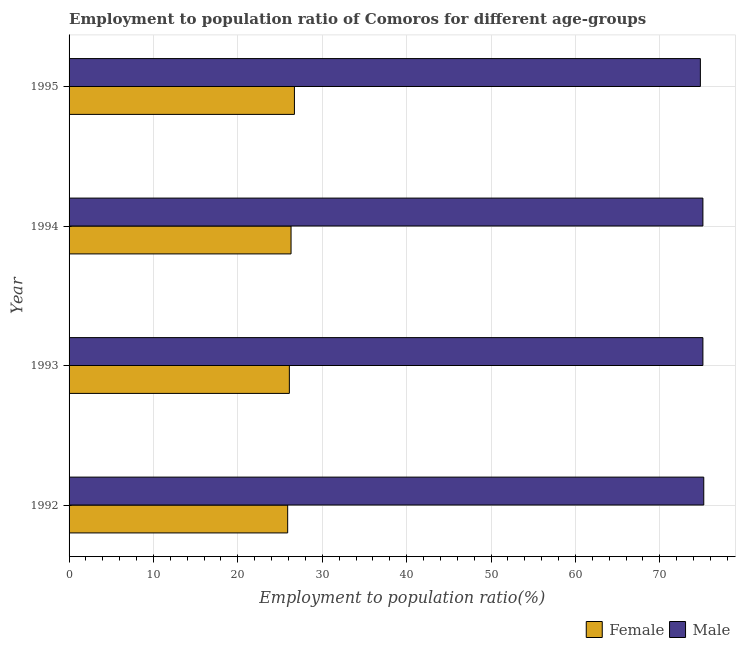Are the number of bars per tick equal to the number of legend labels?
Your answer should be compact. Yes. How many bars are there on the 4th tick from the top?
Keep it short and to the point. 2. What is the label of the 4th group of bars from the top?
Make the answer very short. 1992. What is the employment to population ratio(female) in 1992?
Offer a very short reply. 25.9. Across all years, what is the maximum employment to population ratio(male)?
Provide a short and direct response. 75.2. Across all years, what is the minimum employment to population ratio(male)?
Provide a succinct answer. 74.8. What is the total employment to population ratio(female) in the graph?
Provide a succinct answer. 105. What is the difference between the employment to population ratio(male) in 1992 and that in 1995?
Make the answer very short. 0.4. What is the difference between the employment to population ratio(female) in 1995 and the employment to population ratio(male) in 1993?
Make the answer very short. -48.4. What is the average employment to population ratio(male) per year?
Your response must be concise. 75.05. In the year 1992, what is the difference between the employment to population ratio(female) and employment to population ratio(male)?
Offer a terse response. -49.3. What is the ratio of the employment to population ratio(male) in 1993 to that in 1994?
Make the answer very short. 1. What is the difference between the highest and the second highest employment to population ratio(male)?
Provide a succinct answer. 0.1. What does the 1st bar from the top in 1994 represents?
Provide a succinct answer. Male. What does the 2nd bar from the bottom in 1995 represents?
Provide a succinct answer. Male. How many bars are there?
Your answer should be very brief. 8. Are all the bars in the graph horizontal?
Give a very brief answer. Yes. What is the difference between two consecutive major ticks on the X-axis?
Keep it short and to the point. 10. Are the values on the major ticks of X-axis written in scientific E-notation?
Offer a very short reply. No. Does the graph contain grids?
Make the answer very short. Yes. Where does the legend appear in the graph?
Your answer should be very brief. Bottom right. What is the title of the graph?
Provide a succinct answer. Employment to population ratio of Comoros for different age-groups. What is the Employment to population ratio(%) of Female in 1992?
Your response must be concise. 25.9. What is the Employment to population ratio(%) in Male in 1992?
Give a very brief answer. 75.2. What is the Employment to population ratio(%) in Female in 1993?
Make the answer very short. 26.1. What is the Employment to population ratio(%) in Male in 1993?
Your response must be concise. 75.1. What is the Employment to population ratio(%) in Female in 1994?
Make the answer very short. 26.3. What is the Employment to population ratio(%) of Male in 1994?
Keep it short and to the point. 75.1. What is the Employment to population ratio(%) in Female in 1995?
Provide a succinct answer. 26.7. What is the Employment to population ratio(%) in Male in 1995?
Give a very brief answer. 74.8. Across all years, what is the maximum Employment to population ratio(%) of Female?
Provide a succinct answer. 26.7. Across all years, what is the maximum Employment to population ratio(%) of Male?
Your answer should be very brief. 75.2. Across all years, what is the minimum Employment to population ratio(%) of Female?
Keep it short and to the point. 25.9. Across all years, what is the minimum Employment to population ratio(%) of Male?
Ensure brevity in your answer.  74.8. What is the total Employment to population ratio(%) of Female in the graph?
Your answer should be compact. 105. What is the total Employment to population ratio(%) in Male in the graph?
Your response must be concise. 300.2. What is the difference between the Employment to population ratio(%) in Female in 1992 and that in 1993?
Your response must be concise. -0.2. What is the difference between the Employment to population ratio(%) in Male in 1992 and that in 1994?
Your response must be concise. 0.1. What is the difference between the Employment to population ratio(%) in Female in 1992 and that in 1995?
Make the answer very short. -0.8. What is the difference between the Employment to population ratio(%) of Male in 1992 and that in 1995?
Your answer should be very brief. 0.4. What is the difference between the Employment to population ratio(%) of Female in 1993 and that in 1995?
Ensure brevity in your answer.  -0.6. What is the difference between the Employment to population ratio(%) in Female in 1992 and the Employment to population ratio(%) in Male in 1993?
Keep it short and to the point. -49.2. What is the difference between the Employment to population ratio(%) in Female in 1992 and the Employment to population ratio(%) in Male in 1994?
Your response must be concise. -49.2. What is the difference between the Employment to population ratio(%) of Female in 1992 and the Employment to population ratio(%) of Male in 1995?
Your answer should be compact. -48.9. What is the difference between the Employment to population ratio(%) of Female in 1993 and the Employment to population ratio(%) of Male in 1994?
Ensure brevity in your answer.  -49. What is the difference between the Employment to population ratio(%) in Female in 1993 and the Employment to population ratio(%) in Male in 1995?
Your response must be concise. -48.7. What is the difference between the Employment to population ratio(%) in Female in 1994 and the Employment to population ratio(%) in Male in 1995?
Your answer should be compact. -48.5. What is the average Employment to population ratio(%) in Female per year?
Provide a short and direct response. 26.25. What is the average Employment to population ratio(%) in Male per year?
Your answer should be compact. 75.05. In the year 1992, what is the difference between the Employment to population ratio(%) in Female and Employment to population ratio(%) in Male?
Your response must be concise. -49.3. In the year 1993, what is the difference between the Employment to population ratio(%) of Female and Employment to population ratio(%) of Male?
Ensure brevity in your answer.  -49. In the year 1994, what is the difference between the Employment to population ratio(%) of Female and Employment to population ratio(%) of Male?
Offer a very short reply. -48.8. In the year 1995, what is the difference between the Employment to population ratio(%) of Female and Employment to population ratio(%) of Male?
Provide a short and direct response. -48.1. What is the ratio of the Employment to population ratio(%) of Female in 1992 to that in 1993?
Your answer should be compact. 0.99. What is the ratio of the Employment to population ratio(%) in Female in 1992 to that in 1994?
Offer a very short reply. 0.98. What is the ratio of the Employment to population ratio(%) in Male in 1992 to that in 1994?
Your response must be concise. 1. What is the ratio of the Employment to population ratio(%) in Female in 1992 to that in 1995?
Provide a short and direct response. 0.97. What is the ratio of the Employment to population ratio(%) in Male in 1993 to that in 1994?
Ensure brevity in your answer.  1. What is the ratio of the Employment to population ratio(%) of Female in 1993 to that in 1995?
Provide a short and direct response. 0.98. What is the ratio of the Employment to population ratio(%) of Male in 1993 to that in 1995?
Give a very brief answer. 1. What is the ratio of the Employment to population ratio(%) of Female in 1994 to that in 1995?
Offer a very short reply. 0.98. What is the ratio of the Employment to population ratio(%) in Male in 1994 to that in 1995?
Provide a succinct answer. 1. What is the difference between the highest and the second highest Employment to population ratio(%) of Male?
Make the answer very short. 0.1. 